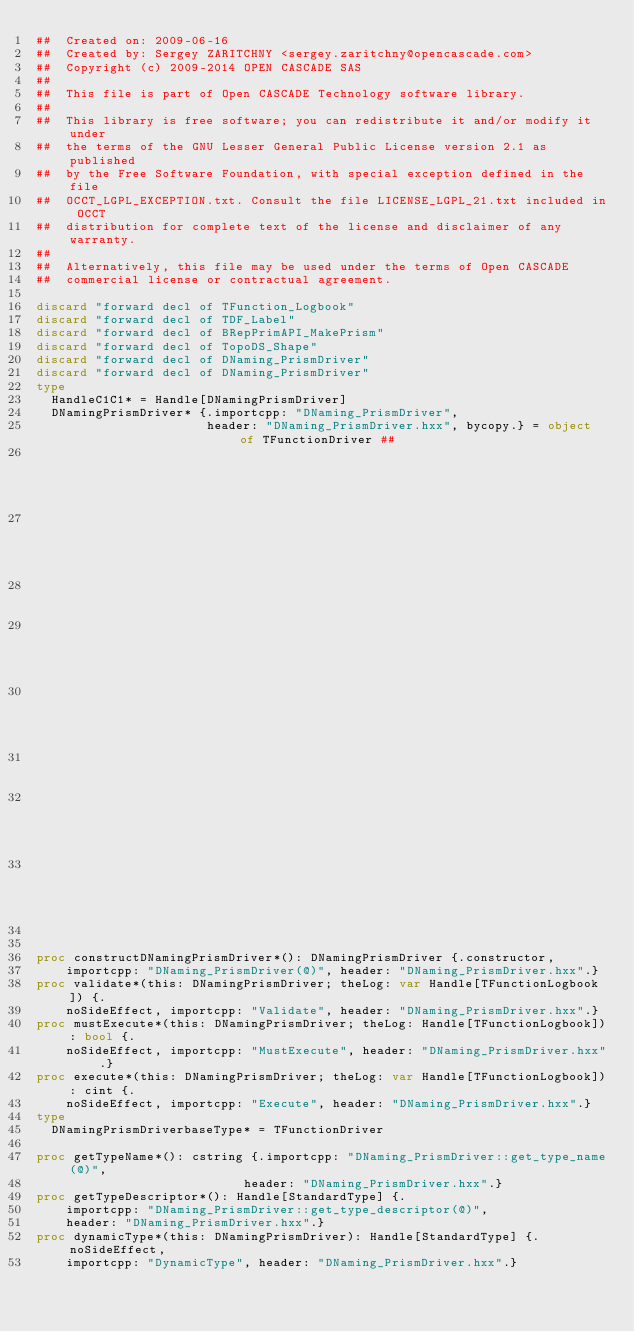<code> <loc_0><loc_0><loc_500><loc_500><_Nim_>##  Created on: 2009-06-16
##  Created by: Sergey ZARITCHNY <sergey.zaritchny@opencascade.com>
##  Copyright (c) 2009-2014 OPEN CASCADE SAS
##
##  This file is part of Open CASCADE Technology software library.
##
##  This library is free software; you can redistribute it and/or modify it under
##  the terms of the GNU Lesser General Public License version 2.1 as published
##  by the Free Software Foundation, with special exception defined in the file
##  OCCT_LGPL_EXCEPTION.txt. Consult the file LICENSE_LGPL_21.txt included in OCCT
##  distribution for complete text of the license and disclaimer of any warranty.
##
##  Alternatively, this file may be used under the terms of Open CASCADE
##  commercial license or contractual agreement.

discard "forward decl of TFunction_Logbook"
discard "forward decl of TDF_Label"
discard "forward decl of BRepPrimAPI_MakePrism"
discard "forward decl of TopoDS_Shape"
discard "forward decl of DNaming_PrismDriver"
discard "forward decl of DNaming_PrismDriver"
type
  HandleC1C1* = Handle[DNamingPrismDriver]
  DNamingPrismDriver* {.importcpp: "DNaming_PrismDriver",
                       header: "DNaming_PrismDriver.hxx", bycopy.} = object of TFunctionDriver ##
                                                                                        ## !
                                                                                        ## Constructor
                                                                                        ##
                                                                                        ## !
                                                                                        ## validation
                                                                                        ##
                                                                                        ## !
                                                                                        ## ==========


proc constructDNamingPrismDriver*(): DNamingPrismDriver {.constructor,
    importcpp: "DNaming_PrismDriver(@)", header: "DNaming_PrismDriver.hxx".}
proc validate*(this: DNamingPrismDriver; theLog: var Handle[TFunctionLogbook]) {.
    noSideEffect, importcpp: "Validate", header: "DNaming_PrismDriver.hxx".}
proc mustExecute*(this: DNamingPrismDriver; theLog: Handle[TFunctionLogbook]): bool {.
    noSideEffect, importcpp: "MustExecute", header: "DNaming_PrismDriver.hxx".}
proc execute*(this: DNamingPrismDriver; theLog: var Handle[TFunctionLogbook]): cint {.
    noSideEffect, importcpp: "Execute", header: "DNaming_PrismDriver.hxx".}
type
  DNamingPrismDriverbaseType* = TFunctionDriver

proc getTypeName*(): cstring {.importcpp: "DNaming_PrismDriver::get_type_name(@)",
                            header: "DNaming_PrismDriver.hxx".}
proc getTypeDescriptor*(): Handle[StandardType] {.
    importcpp: "DNaming_PrismDriver::get_type_descriptor(@)",
    header: "DNaming_PrismDriver.hxx".}
proc dynamicType*(this: DNamingPrismDriver): Handle[StandardType] {.noSideEffect,
    importcpp: "DynamicType", header: "DNaming_PrismDriver.hxx".}

























</code> 